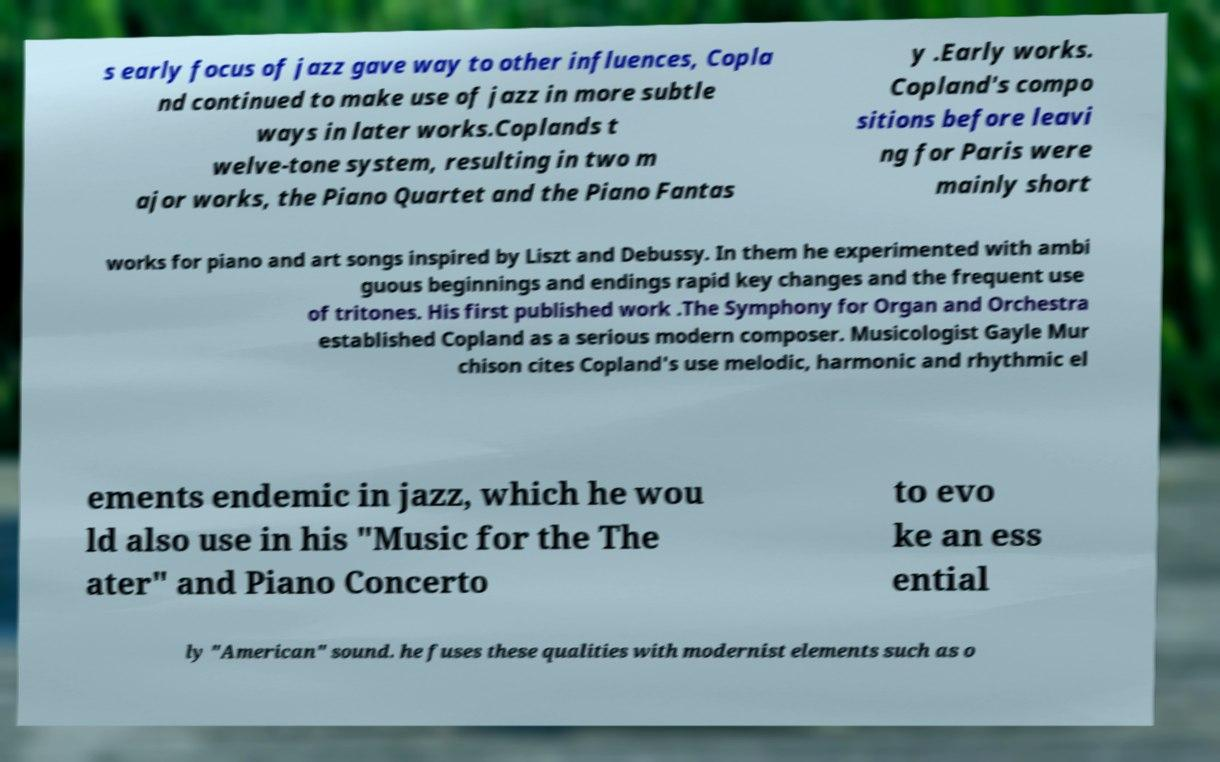I need the written content from this picture converted into text. Can you do that? s early focus of jazz gave way to other influences, Copla nd continued to make use of jazz in more subtle ways in later works.Coplands t welve-tone system, resulting in two m ajor works, the Piano Quartet and the Piano Fantas y .Early works. Copland's compo sitions before leavi ng for Paris were mainly short works for piano and art songs inspired by Liszt and Debussy. In them he experimented with ambi guous beginnings and endings rapid key changes and the frequent use of tritones. His first published work .The Symphony for Organ and Orchestra established Copland as a serious modern composer. Musicologist Gayle Mur chison cites Copland's use melodic, harmonic and rhythmic el ements endemic in jazz, which he wou ld also use in his "Music for the The ater" and Piano Concerto to evo ke an ess ential ly "American" sound. he fuses these qualities with modernist elements such as o 